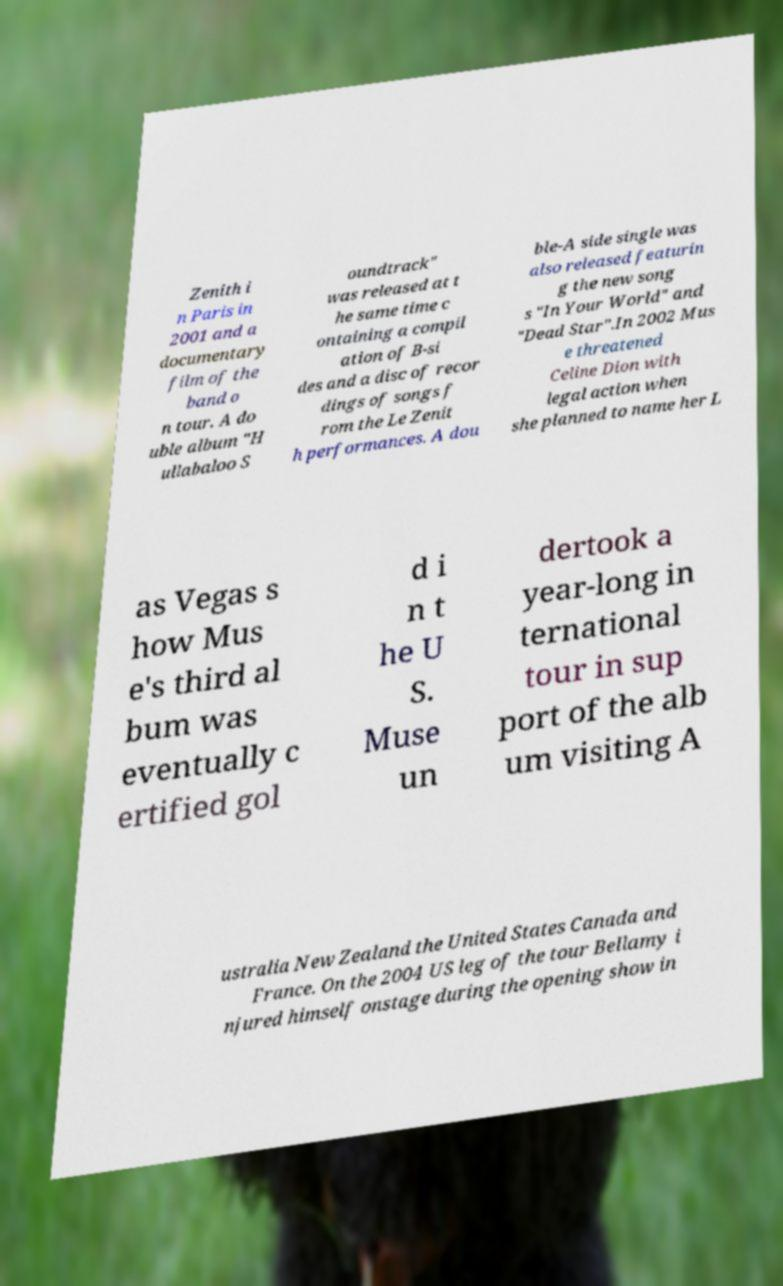Could you extract and type out the text from this image? Zenith i n Paris in 2001 and a documentary film of the band o n tour. A do uble album "H ullabaloo S oundtrack" was released at t he same time c ontaining a compil ation of B-si des and a disc of recor dings of songs f rom the Le Zenit h performances. A dou ble-A side single was also released featurin g the new song s "In Your World" and "Dead Star".In 2002 Mus e threatened Celine Dion with legal action when she planned to name her L as Vegas s how Mus e's third al bum was eventually c ertified gol d i n t he U S. Muse un dertook a year-long in ternational tour in sup port of the alb um visiting A ustralia New Zealand the United States Canada and France. On the 2004 US leg of the tour Bellamy i njured himself onstage during the opening show in 